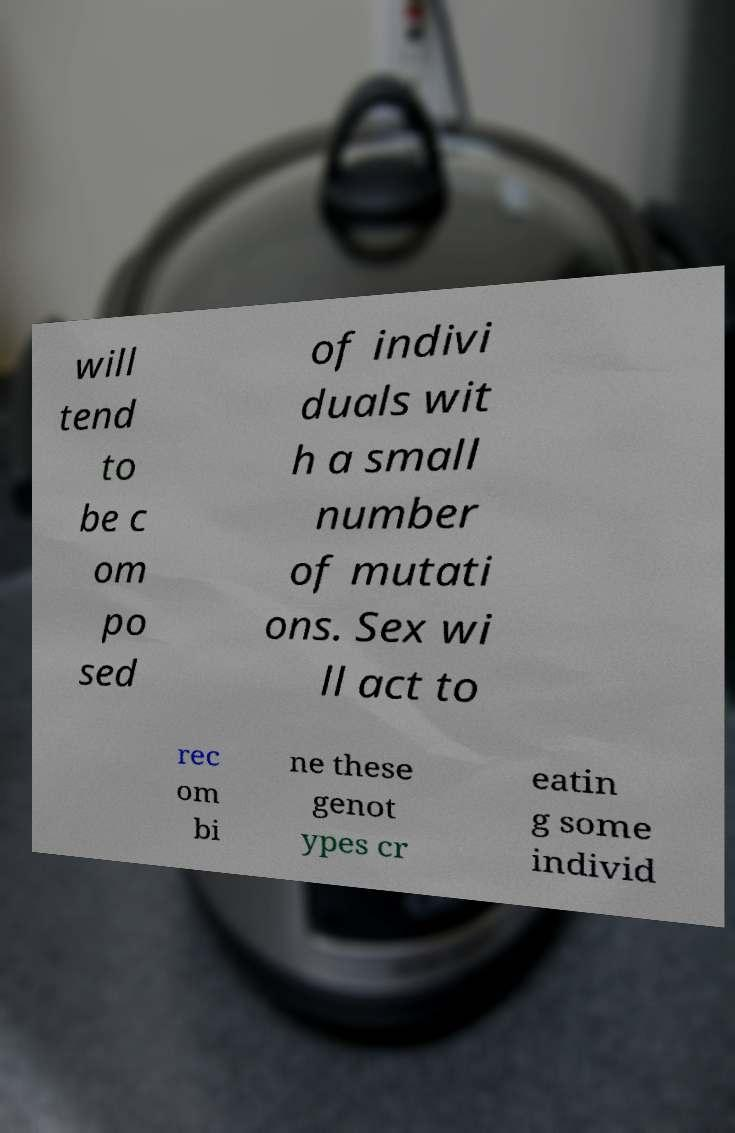What messages or text are displayed in this image? I need them in a readable, typed format. will tend to be c om po sed of indivi duals wit h a small number of mutati ons. Sex wi ll act to rec om bi ne these genot ypes cr eatin g some individ 